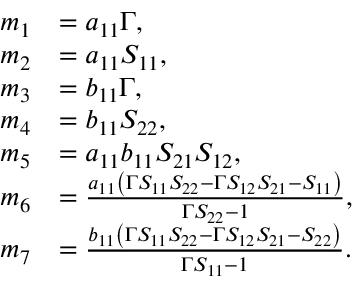Convert formula to latex. <formula><loc_0><loc_0><loc_500><loc_500>\begin{array} { r l } { m _ { 1 } } & { = a _ { 1 1 } \Gamma , } \\ { m _ { 2 } } & { = a _ { 1 1 } S _ { 1 1 } , } \\ { m _ { 3 } } & { = b _ { 1 1 } \Gamma , } \\ { m _ { 4 } } & { = b _ { 1 1 } S _ { 2 2 } , } \\ { m _ { 5 } } & { = a _ { 1 1 } b _ { 1 1 } S _ { 2 1 } S _ { 1 2 } , } \\ { m _ { 6 } } & { = \frac { a _ { 1 1 } \left ( \Gamma S _ { 1 1 } S _ { 2 2 } - \Gamma S _ { 1 2 } S _ { 2 1 } - S _ { 1 1 } \right ) } { \Gamma S _ { 2 2 } - 1 } , } \\ { m _ { 7 } } & { = \frac { b _ { 1 1 } \left ( \Gamma S _ { 1 1 } S _ { 2 2 } - \Gamma S _ { 1 2 } S _ { 2 1 } - S _ { 2 2 } \right ) } { \Gamma S _ { 1 1 } - 1 } . } \end{array}</formula> 